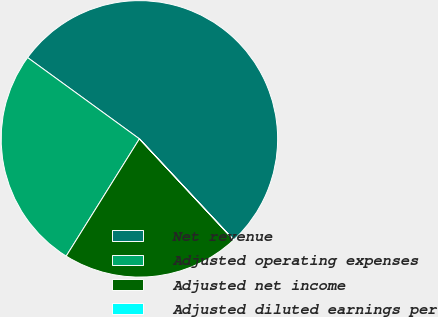Convert chart to OTSL. <chart><loc_0><loc_0><loc_500><loc_500><pie_chart><fcel>Net revenue<fcel>Adjusted operating expenses<fcel>Adjusted net income<fcel>Adjusted diluted earnings per<nl><fcel>53.04%<fcel>26.12%<fcel>20.82%<fcel>0.02%<nl></chart> 